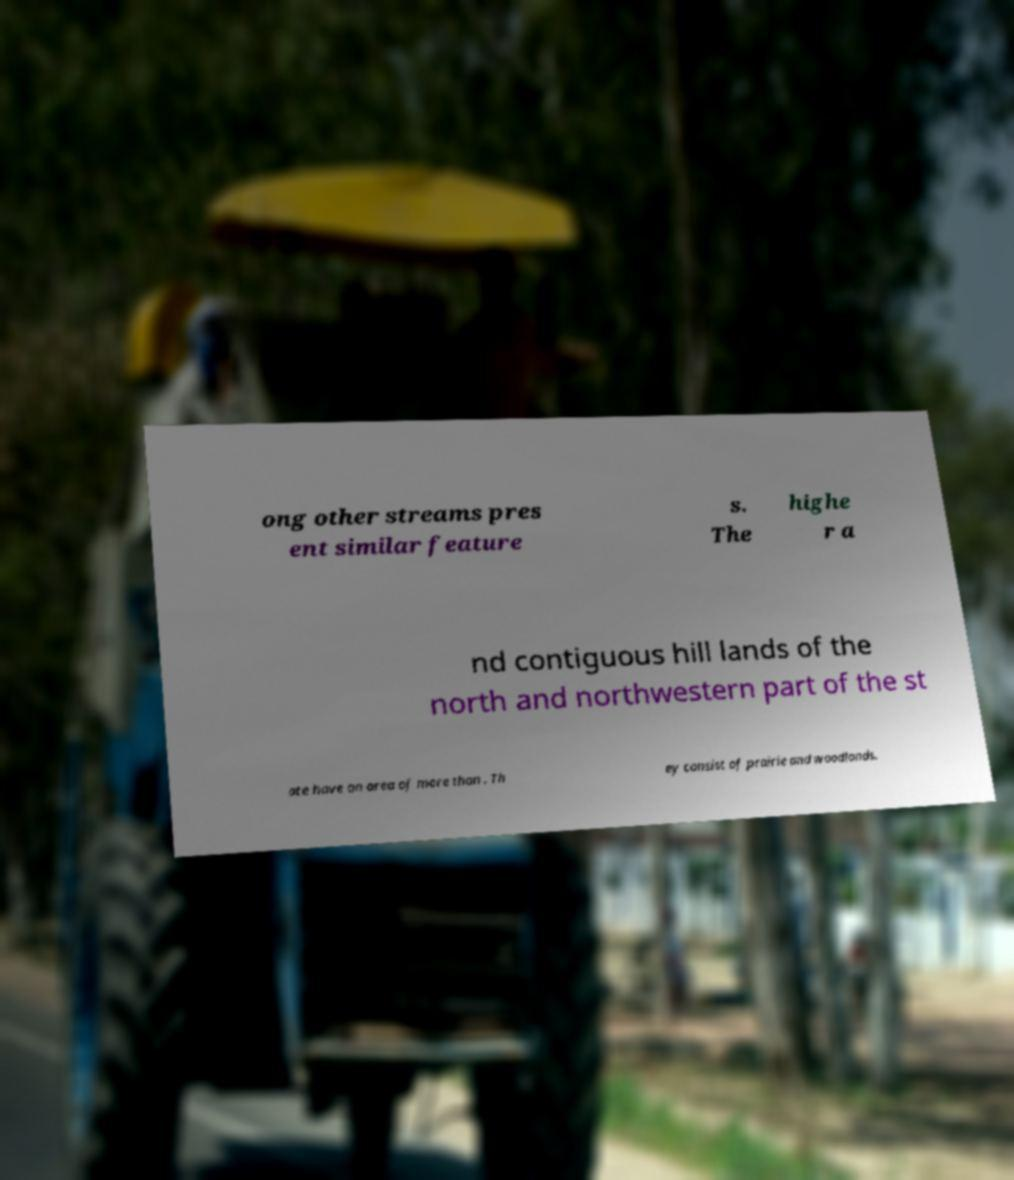Could you extract and type out the text from this image? ong other streams pres ent similar feature s. The highe r a nd contiguous hill lands of the north and northwestern part of the st ate have an area of more than . Th ey consist of prairie and woodlands. 